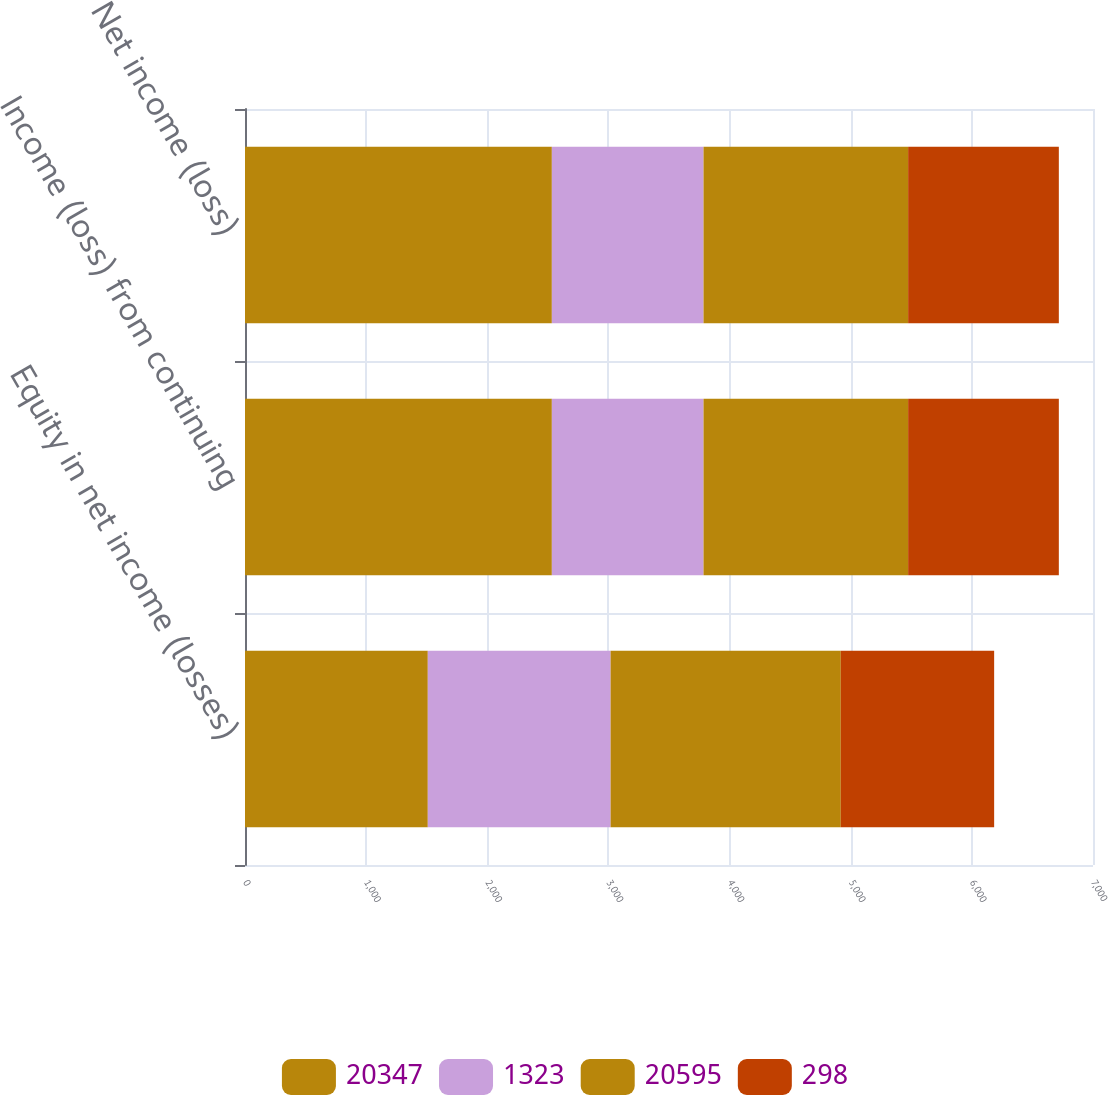Convert chart to OTSL. <chart><loc_0><loc_0><loc_500><loc_500><stacked_bar_chart><ecel><fcel>Equity in net income (losses)<fcel>Income (loss) from continuing<fcel>Net income (loss)<nl><fcel>20347<fcel>1509<fcel>2533<fcel>2533<nl><fcel>1323<fcel>1509<fcel>1252<fcel>1252<nl><fcel>20595<fcel>1900<fcel>1689<fcel>1689<nl><fcel>298<fcel>1266<fcel>1244<fcel>1244<nl></chart> 